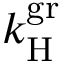Convert formula to latex. <formula><loc_0><loc_0><loc_500><loc_500>k _ { H } ^ { g r }</formula> 